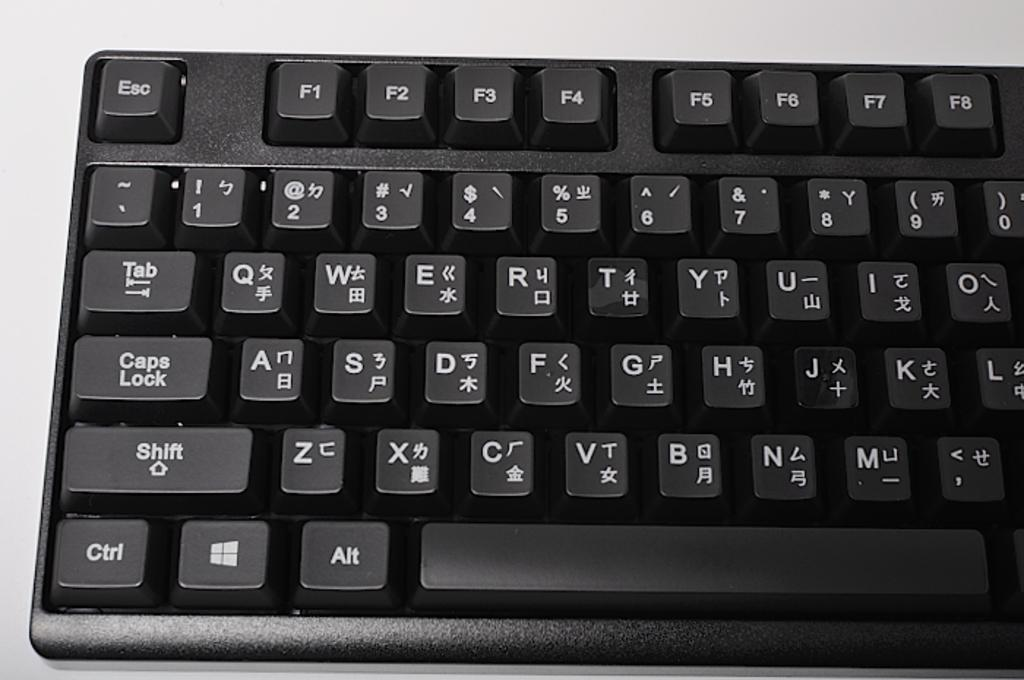<image>
Share a concise interpretation of the image provided. a keyboard with both english and chinese input labels 